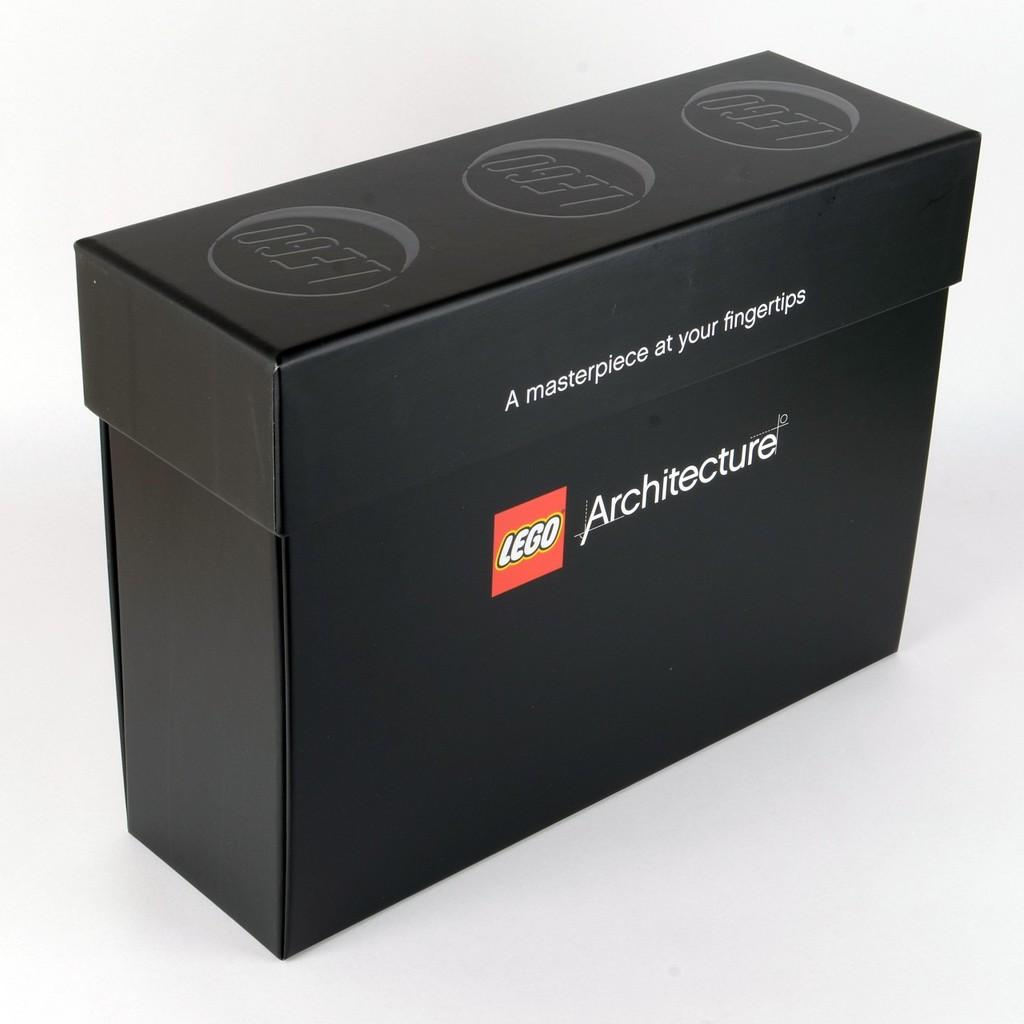<image>
Present a compact description of the photo's key features. A black box of legos with a white background. 